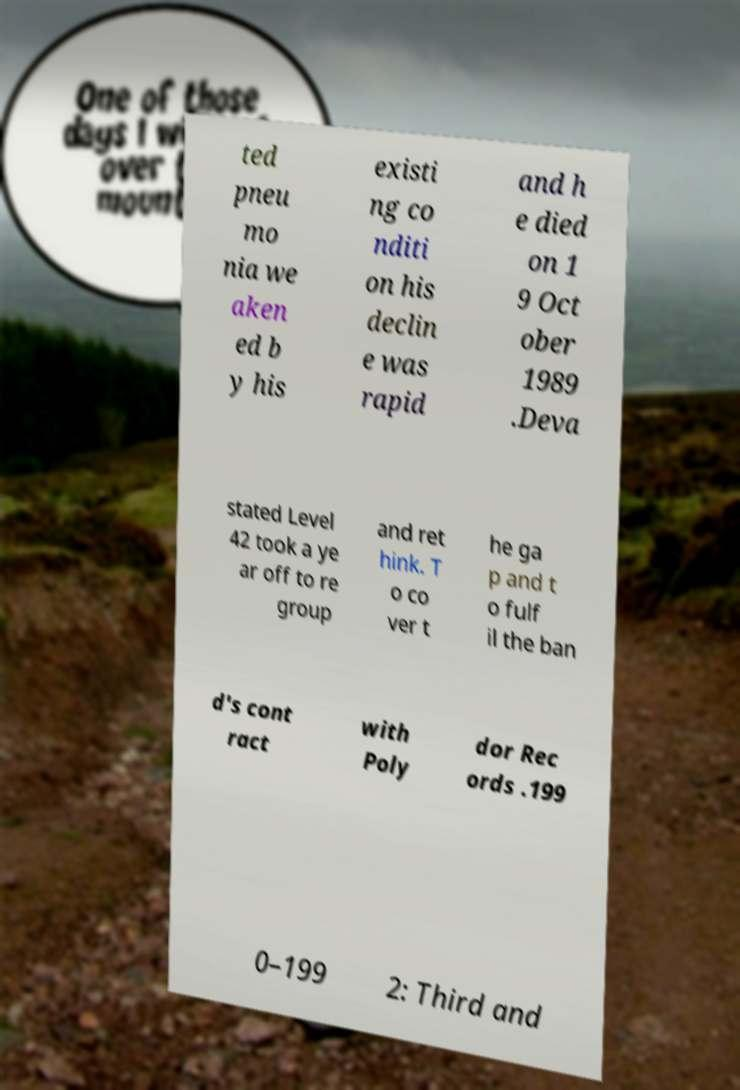Could you assist in decoding the text presented in this image and type it out clearly? ted pneu mo nia we aken ed b y his existi ng co nditi on his declin e was rapid and h e died on 1 9 Oct ober 1989 .Deva stated Level 42 took a ye ar off to re group and ret hink. T o co ver t he ga p and t o fulf il the ban d's cont ract with Poly dor Rec ords .199 0–199 2: Third and 